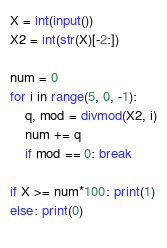<code> <loc_0><loc_0><loc_500><loc_500><_Python_>X = int(input())
X2 = int(str(X)[-2:])

num = 0
for i in range(5, 0, -1):
    q, mod = divmod(X2, i)
    num += q
    if mod == 0: break
    
if X >= num*100: print(1)
else: print(0)  
    
</code> 